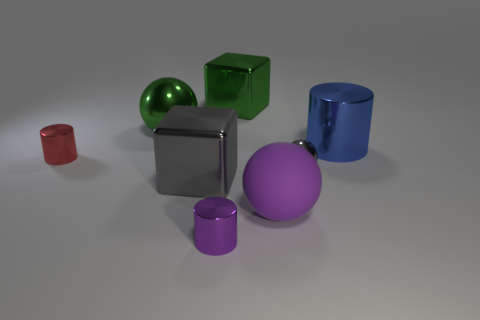Subtract all big metallic cylinders. How many cylinders are left? 2 Add 2 red things. How many objects exist? 10 Subtract all cubes. How many objects are left? 6 Subtract 0 cyan balls. How many objects are left? 8 Subtract all metal cylinders. Subtract all large blue metallic cylinders. How many objects are left? 4 Add 4 red cylinders. How many red cylinders are left? 5 Add 2 large matte balls. How many large matte balls exist? 3 